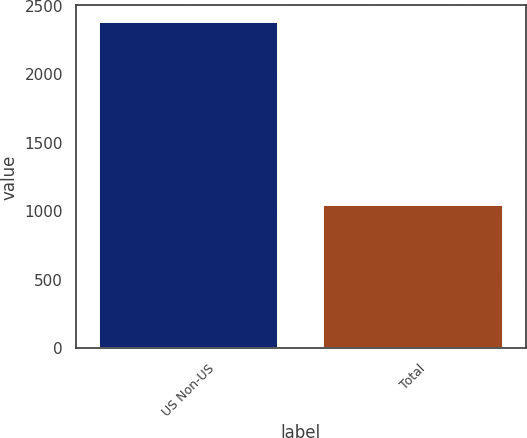<chart> <loc_0><loc_0><loc_500><loc_500><bar_chart><fcel>US Non-US<fcel>Total<nl><fcel>2386<fcel>1044<nl></chart> 